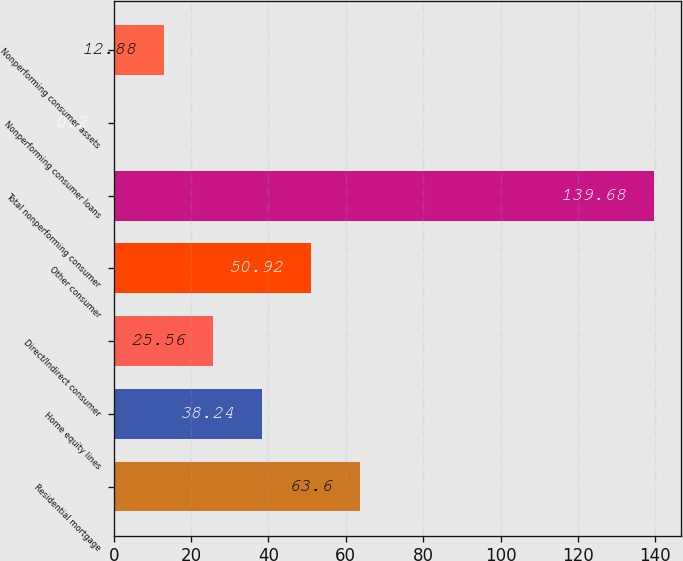<chart> <loc_0><loc_0><loc_500><loc_500><bar_chart><fcel>Residential mortgage<fcel>Home equity lines<fcel>Direct/Indirect consumer<fcel>Other consumer<fcel>Total nonperforming consumer<fcel>Nonperforming consumer loans<fcel>Nonperforming consumer assets<nl><fcel>63.6<fcel>38.24<fcel>25.56<fcel>50.92<fcel>139.68<fcel>0.2<fcel>12.88<nl></chart> 